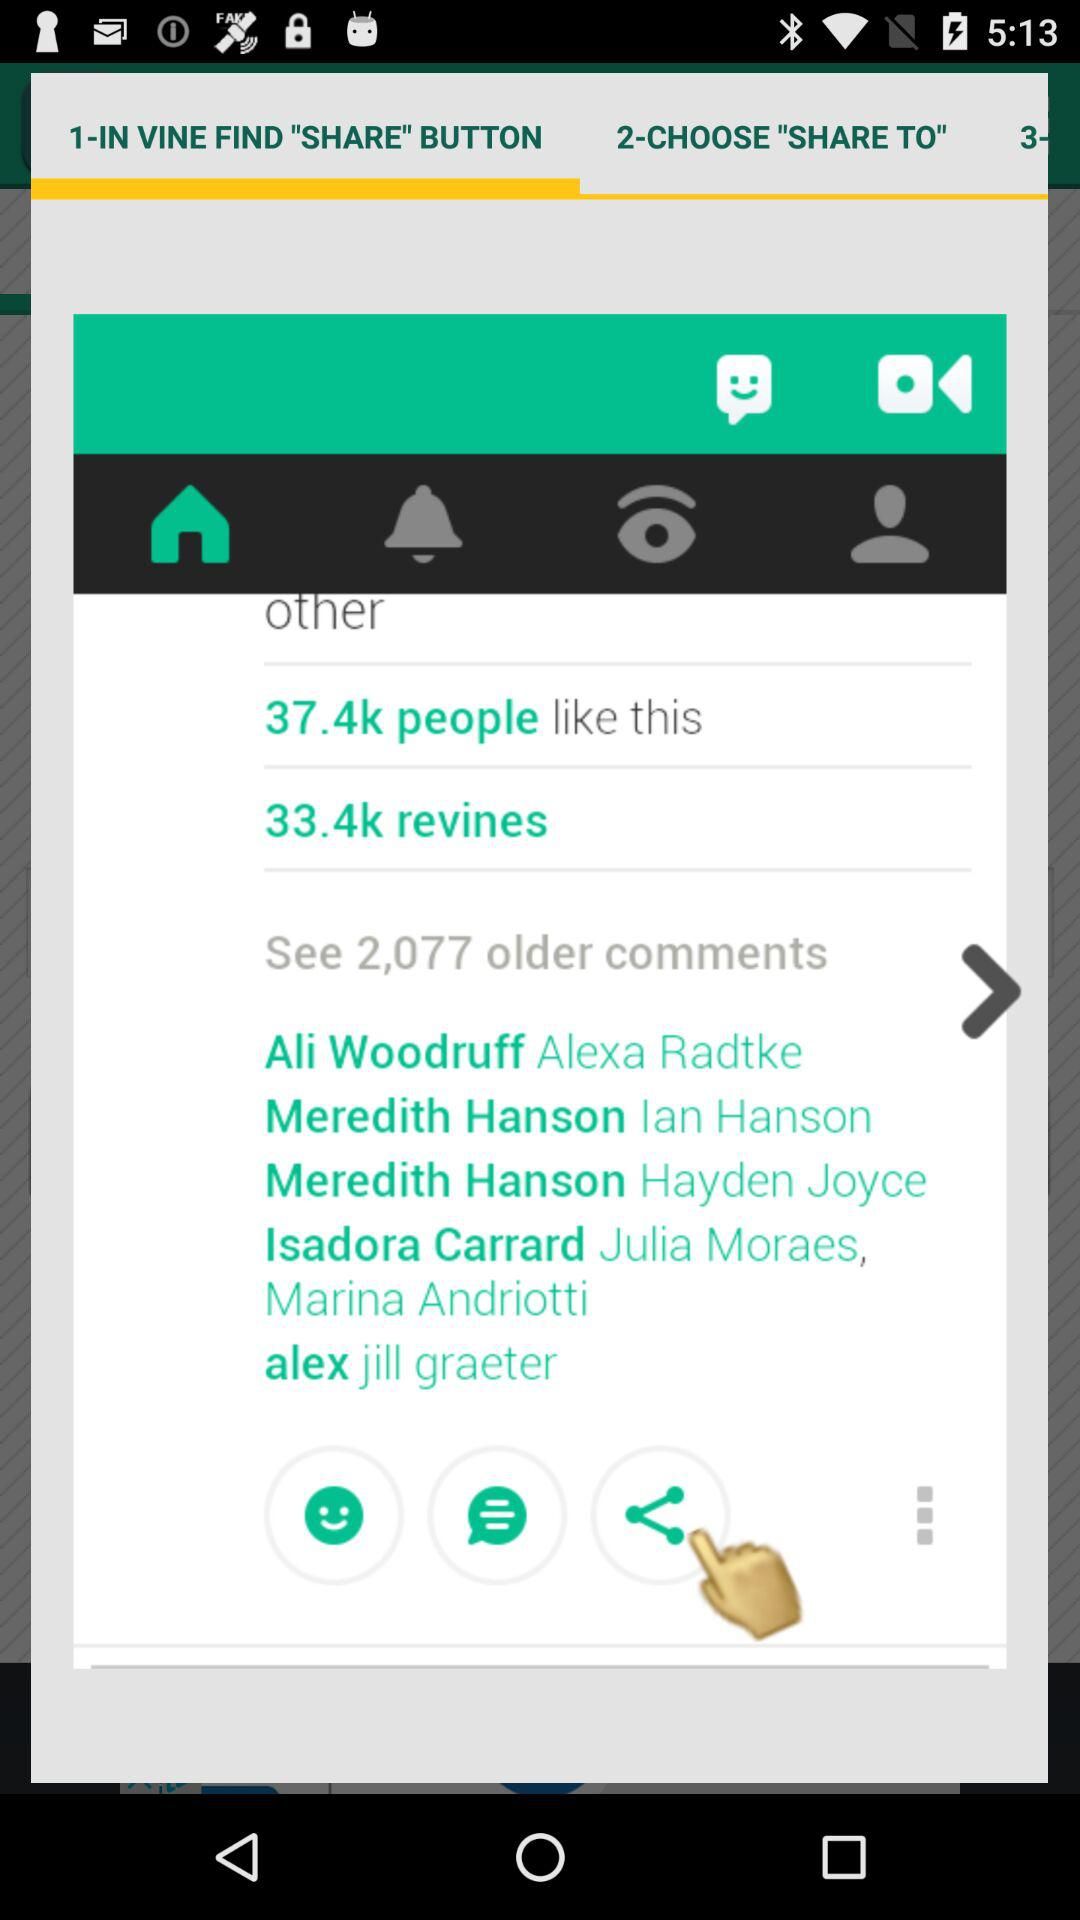How many old comments are there? There are 2,077 old comments. 